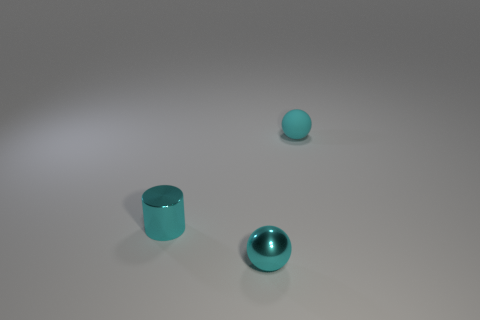What is the size of the cylinder that is the same color as the tiny rubber thing?
Offer a terse response. Small. What number of other tiny metallic cylinders have the same color as the small metallic cylinder?
Your answer should be compact. 0. What is the shape of the small matte object?
Offer a terse response. Sphere. There is a tiny thing that is in front of the tiny rubber sphere and right of the small shiny cylinder; what color is it?
Provide a short and direct response. Cyan. What is the tiny cyan cylinder made of?
Keep it short and to the point. Metal. What is the shape of the shiny object that is to the left of the shiny sphere?
Your answer should be compact. Cylinder. The metallic object that is the same size as the cyan shiny ball is what color?
Offer a very short reply. Cyan. Do the cyan sphere that is behind the shiny cylinder and the small cylinder have the same material?
Provide a succinct answer. No. What is the size of the cyan object that is in front of the tiny cyan rubber ball and to the right of the metal cylinder?
Ensure brevity in your answer.  Small. There is a cyan ball that is in front of the cylinder; how big is it?
Offer a terse response. Small. 